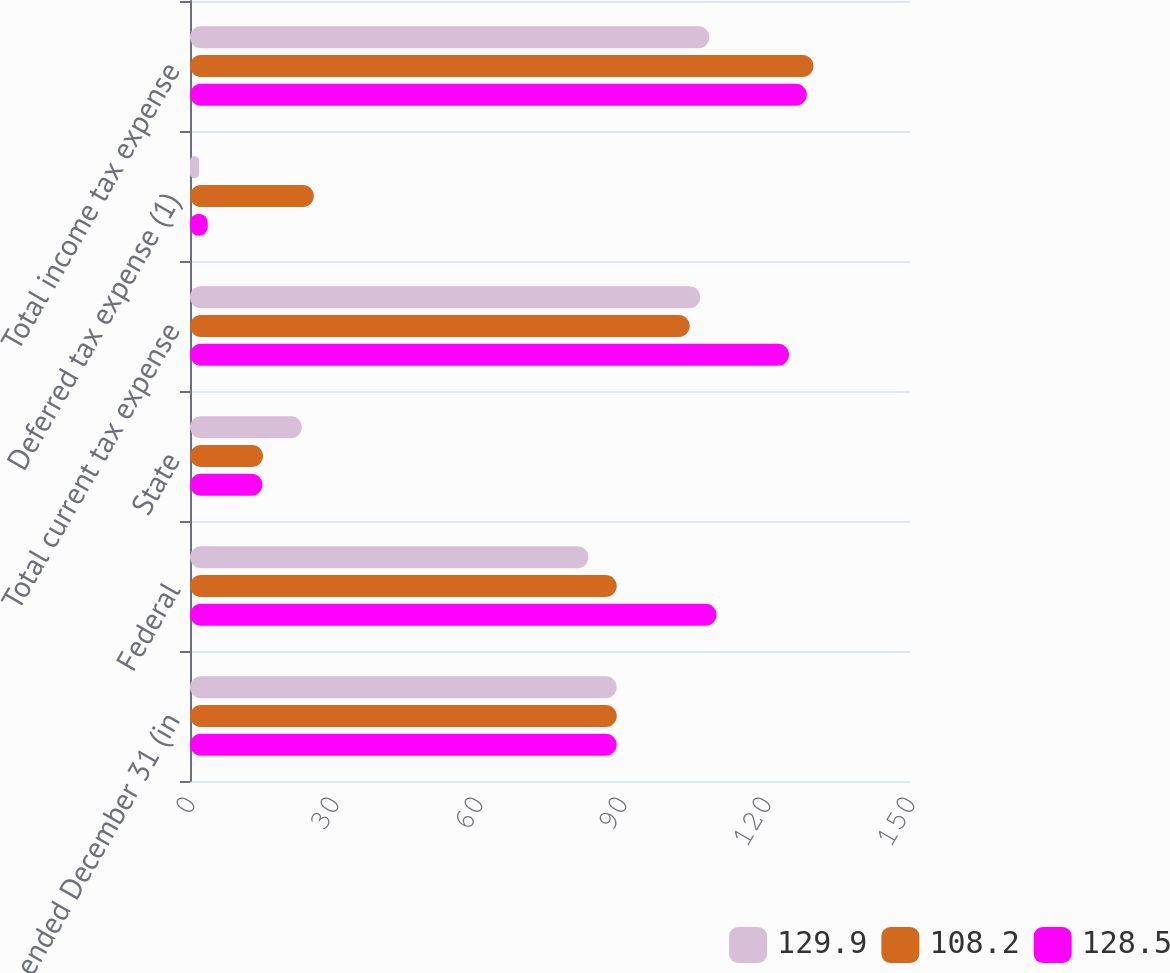<chart> <loc_0><loc_0><loc_500><loc_500><stacked_bar_chart><ecel><fcel>Years ended December 31 (in<fcel>Federal<fcel>State<fcel>Total current tax expense<fcel>Deferred tax expense (1)<fcel>Total income tax expense<nl><fcel>129.9<fcel>88.9<fcel>83<fcel>23.3<fcel>106.3<fcel>1.9<fcel>108.2<nl><fcel>108.2<fcel>88.9<fcel>88.9<fcel>15.2<fcel>104.1<fcel>25.8<fcel>129.9<nl><fcel>128.5<fcel>88.9<fcel>109.7<fcel>15.1<fcel>124.8<fcel>3.7<fcel>128.5<nl></chart> 